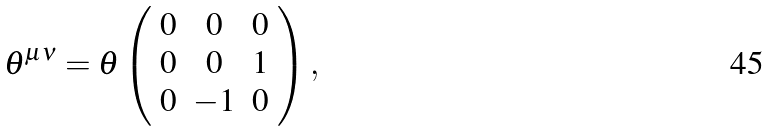<formula> <loc_0><loc_0><loc_500><loc_500>\theta ^ { \mu \nu } = \theta \left ( \begin{array} { c c c } 0 & 0 & 0 \\ 0 & 0 & 1 \\ 0 & - 1 & 0 \end{array} \right ) ,</formula> 